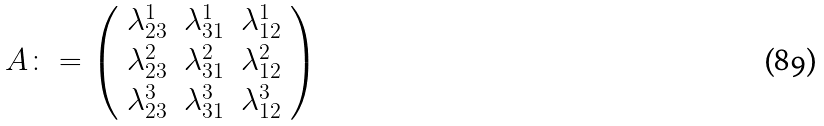Convert formula to latex. <formula><loc_0><loc_0><loc_500><loc_500>A \colon = \left ( \begin{array} { c c c } \lambda _ { 2 3 } ^ { 1 } & \lambda _ { 3 1 } ^ { 1 } & \lambda _ { 1 2 } ^ { 1 } \\ \lambda _ { 2 3 } ^ { 2 } & \lambda _ { 3 1 } ^ { 2 } & \lambda _ { 1 2 } ^ { 2 } \\ \lambda _ { 2 3 } ^ { 3 } & \lambda _ { 3 1 } ^ { 3 } & \lambda _ { 1 2 } ^ { 3 } \\ \end{array} \right )</formula> 